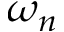Convert formula to latex. <formula><loc_0><loc_0><loc_500><loc_500>\omega _ { n }</formula> 